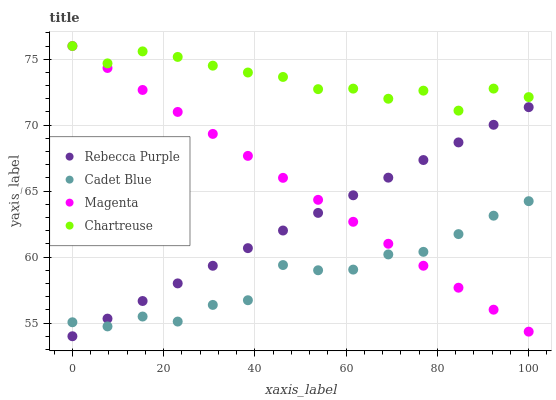Does Cadet Blue have the minimum area under the curve?
Answer yes or no. Yes. Does Chartreuse have the maximum area under the curve?
Answer yes or no. Yes. Does Rebecca Purple have the minimum area under the curve?
Answer yes or no. No. Does Rebecca Purple have the maximum area under the curve?
Answer yes or no. No. Is Rebecca Purple the smoothest?
Answer yes or no. Yes. Is Chartreuse the roughest?
Answer yes or no. Yes. Is Cadet Blue the smoothest?
Answer yes or no. No. Is Cadet Blue the roughest?
Answer yes or no. No. Does Rebecca Purple have the lowest value?
Answer yes or no. Yes. Does Cadet Blue have the lowest value?
Answer yes or no. No. Does Chartreuse have the highest value?
Answer yes or no. Yes. Does Rebecca Purple have the highest value?
Answer yes or no. No. Is Cadet Blue less than Chartreuse?
Answer yes or no. Yes. Is Chartreuse greater than Cadet Blue?
Answer yes or no. Yes. Does Magenta intersect Cadet Blue?
Answer yes or no. Yes. Is Magenta less than Cadet Blue?
Answer yes or no. No. Is Magenta greater than Cadet Blue?
Answer yes or no. No. Does Cadet Blue intersect Chartreuse?
Answer yes or no. No. 